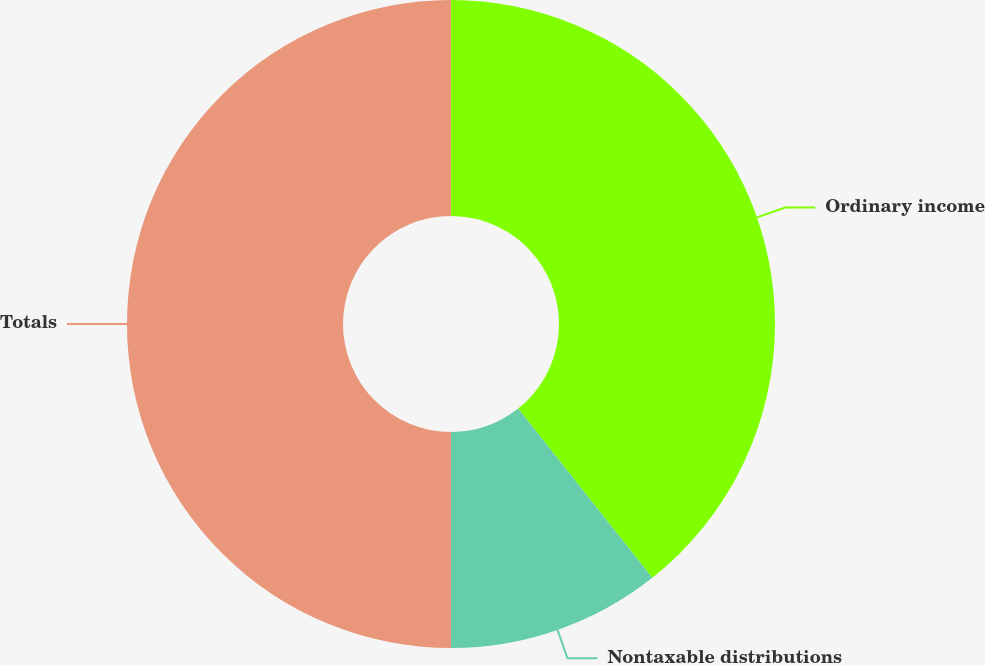<chart> <loc_0><loc_0><loc_500><loc_500><pie_chart><fcel>Ordinary income<fcel>Nontaxable distributions<fcel>Totals<nl><fcel>39.33%<fcel>10.67%<fcel>50.0%<nl></chart> 